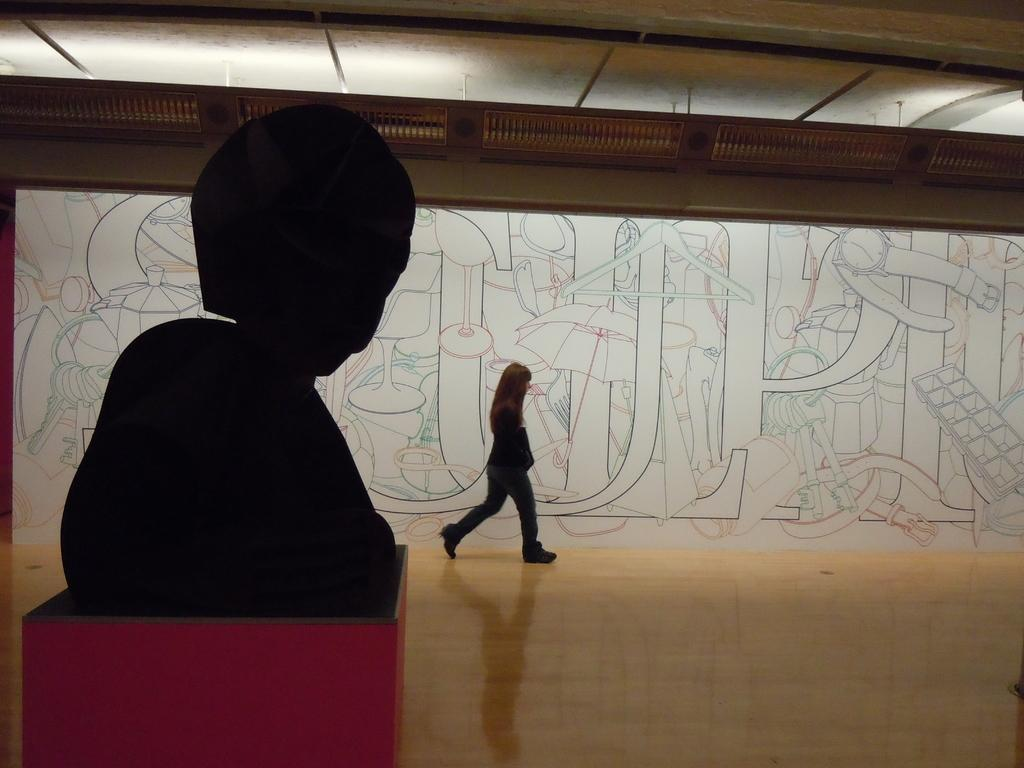What is the main subject in the image? There is a statue in the image. What else can be seen in the image besides the statue? There is a person walking in the image, and the person is walking on the floor. What is visible in the background of the image? There is a drawing on the wall in the background of the image. What type of drawer is present in the image? There is no drawer present in the image. Is there a volcano erupting in the background of the image? No, there is no volcano present in the image. 